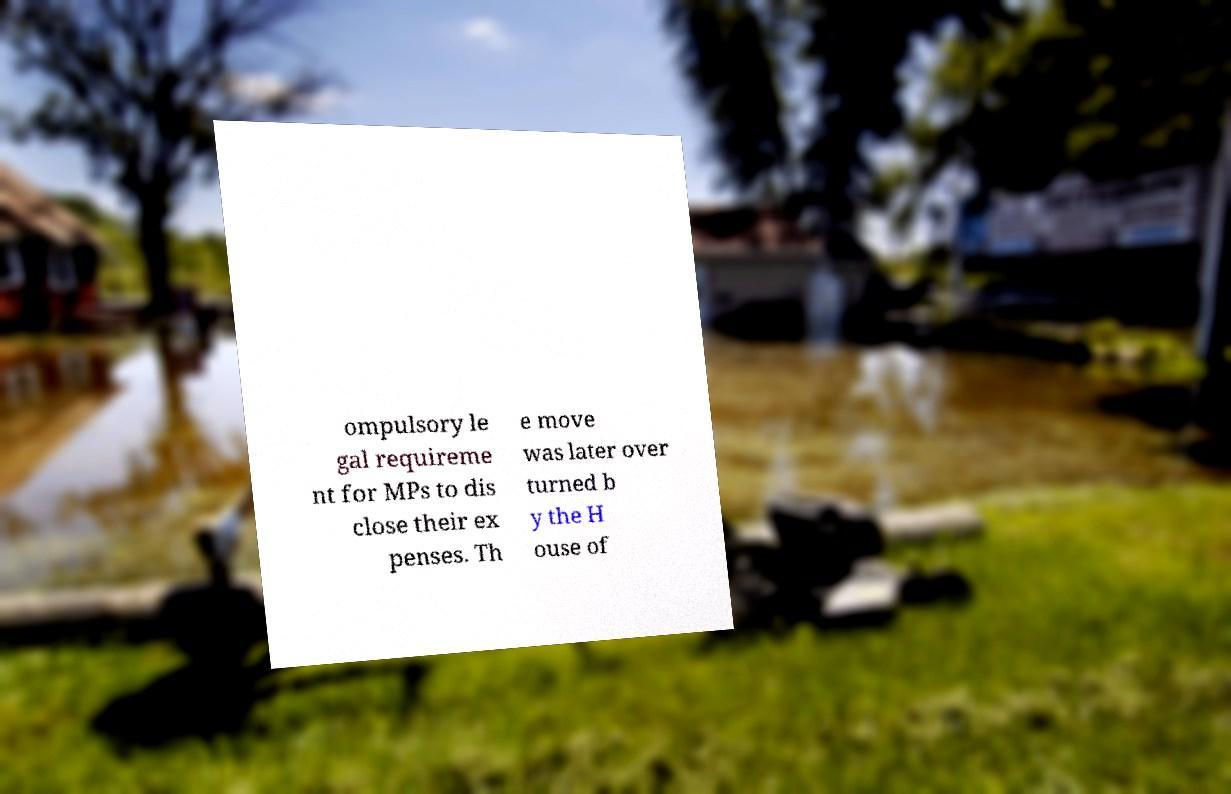Could you extract and type out the text from this image? ompulsory le gal requireme nt for MPs to dis close their ex penses. Th e move was later over turned b y the H ouse of 